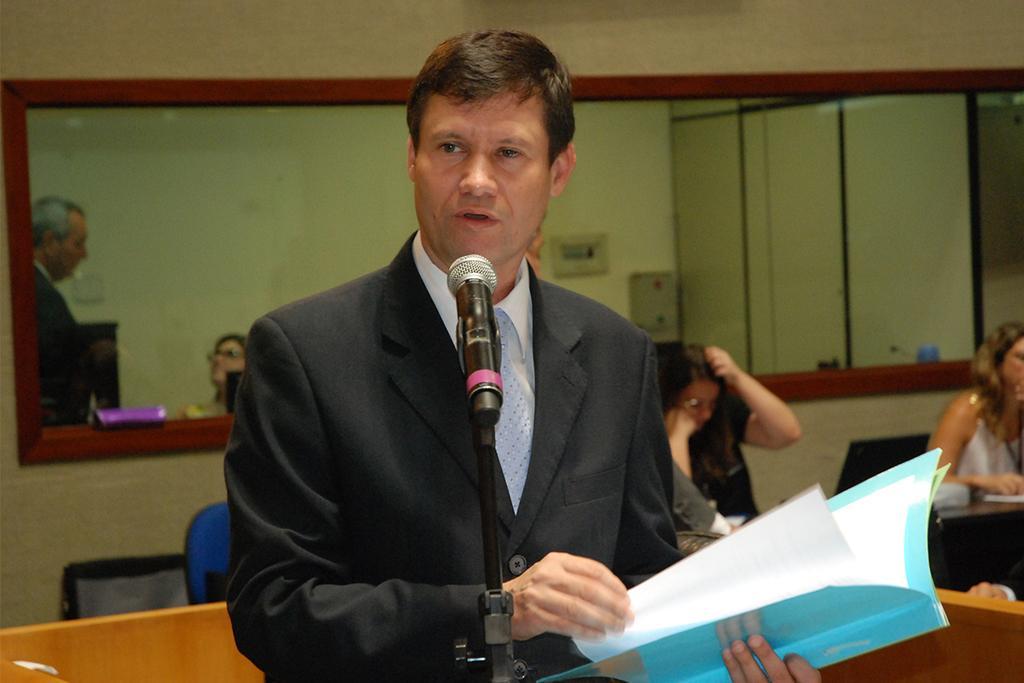Please provide a concise description of this image. In the picture we can see a man standing, he is wearing a black color blazer with white shirt and talking in the microphone which is in the stand and holding some file in the hand with some papers in it and in the background, we can see some people are sitting in the chairs near the desk and behind it we can see a wall with a mirror to it. 